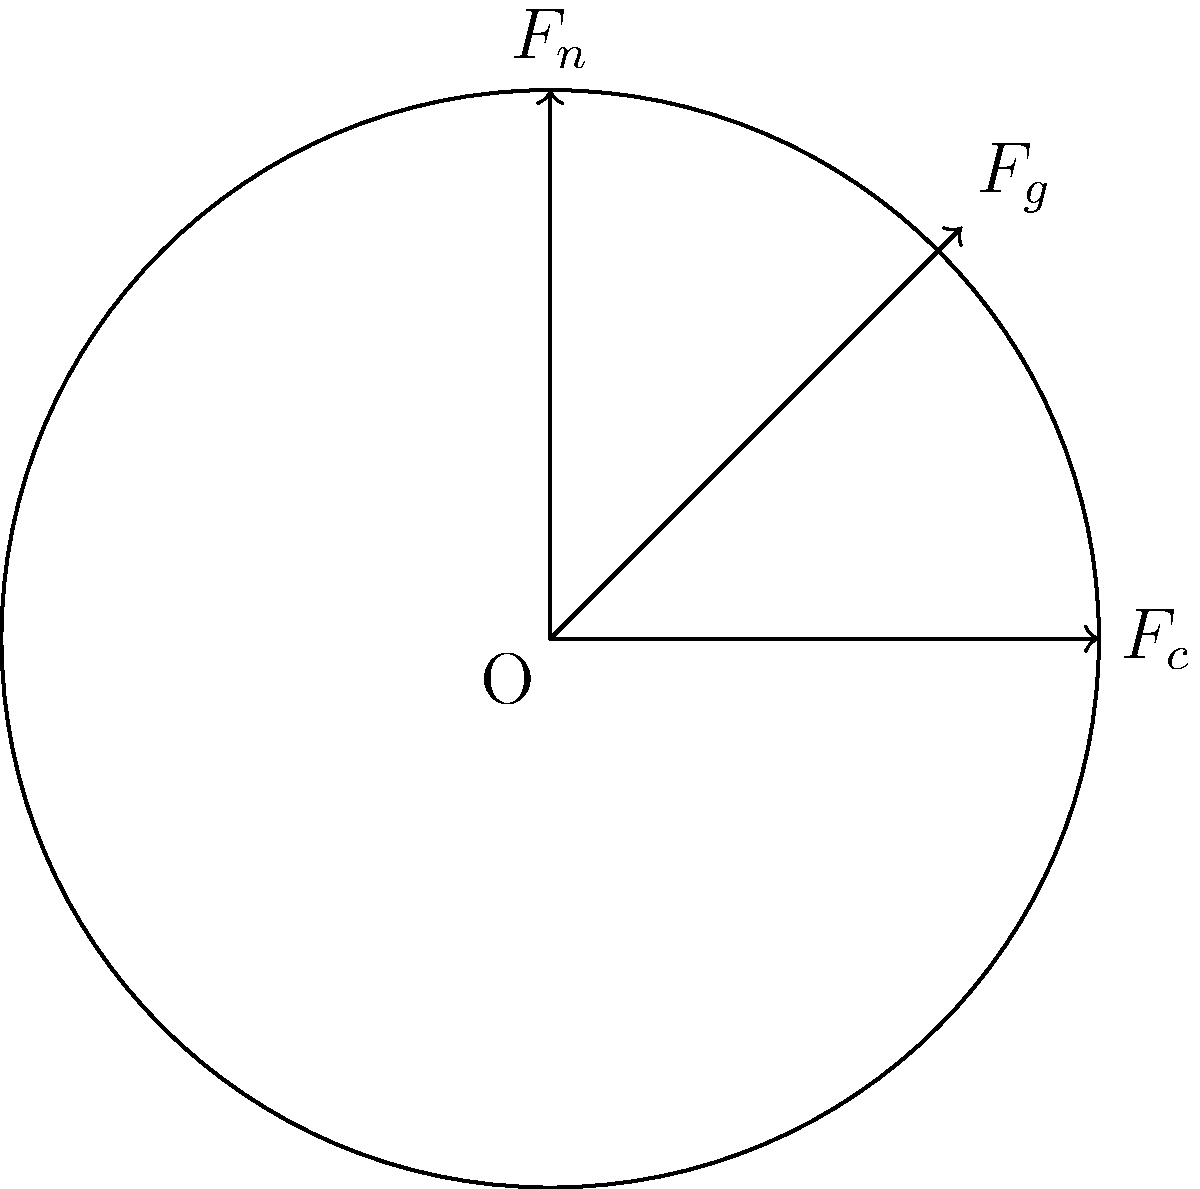During a bike race, you're cornering at high speed. The diagram shows the forces acting on the bicycle wheel at this moment. $F_c$ represents the centripetal force, $F_g$ is the gravitational force, and $F_n$ is the normal force from the road. If the magnitude of $F_g$ is 1000 N and the angle between $F_g$ and $F_n$ is 30°, calculate the magnitude of the centripetal force $F_c$. To solve this problem, we'll follow these steps:

1) First, we need to understand that the three forces ($F_c$, $F_g$, and $F_n$) must be in equilibrium for the bicycle to maintain its cornering motion. This means their vector sum must be zero.

2) We can break this problem into vertical and horizontal components:
   - Vertical: $F_n - F_g \cos(30°) = 0$
   - Horizontal: $F_c - F_g \sin(30°) = 0$

3) We're given that $F_g = 1000$ N. Let's calculate $\sin(30°)$ and $\cos(30°)$:
   $\sin(30°) = 0.5$
   $\cos(30°) = \frac{\sqrt{3}}{2} \approx 0.866$

4) Now, we can solve for $F_c$ using the horizontal equation:
   $F_c = F_g \sin(30°)$
   $F_c = 1000 \cdot 0.5 = 500$ N

Therefore, the magnitude of the centripetal force $F_c$ is 500 N.
Answer: 500 N 